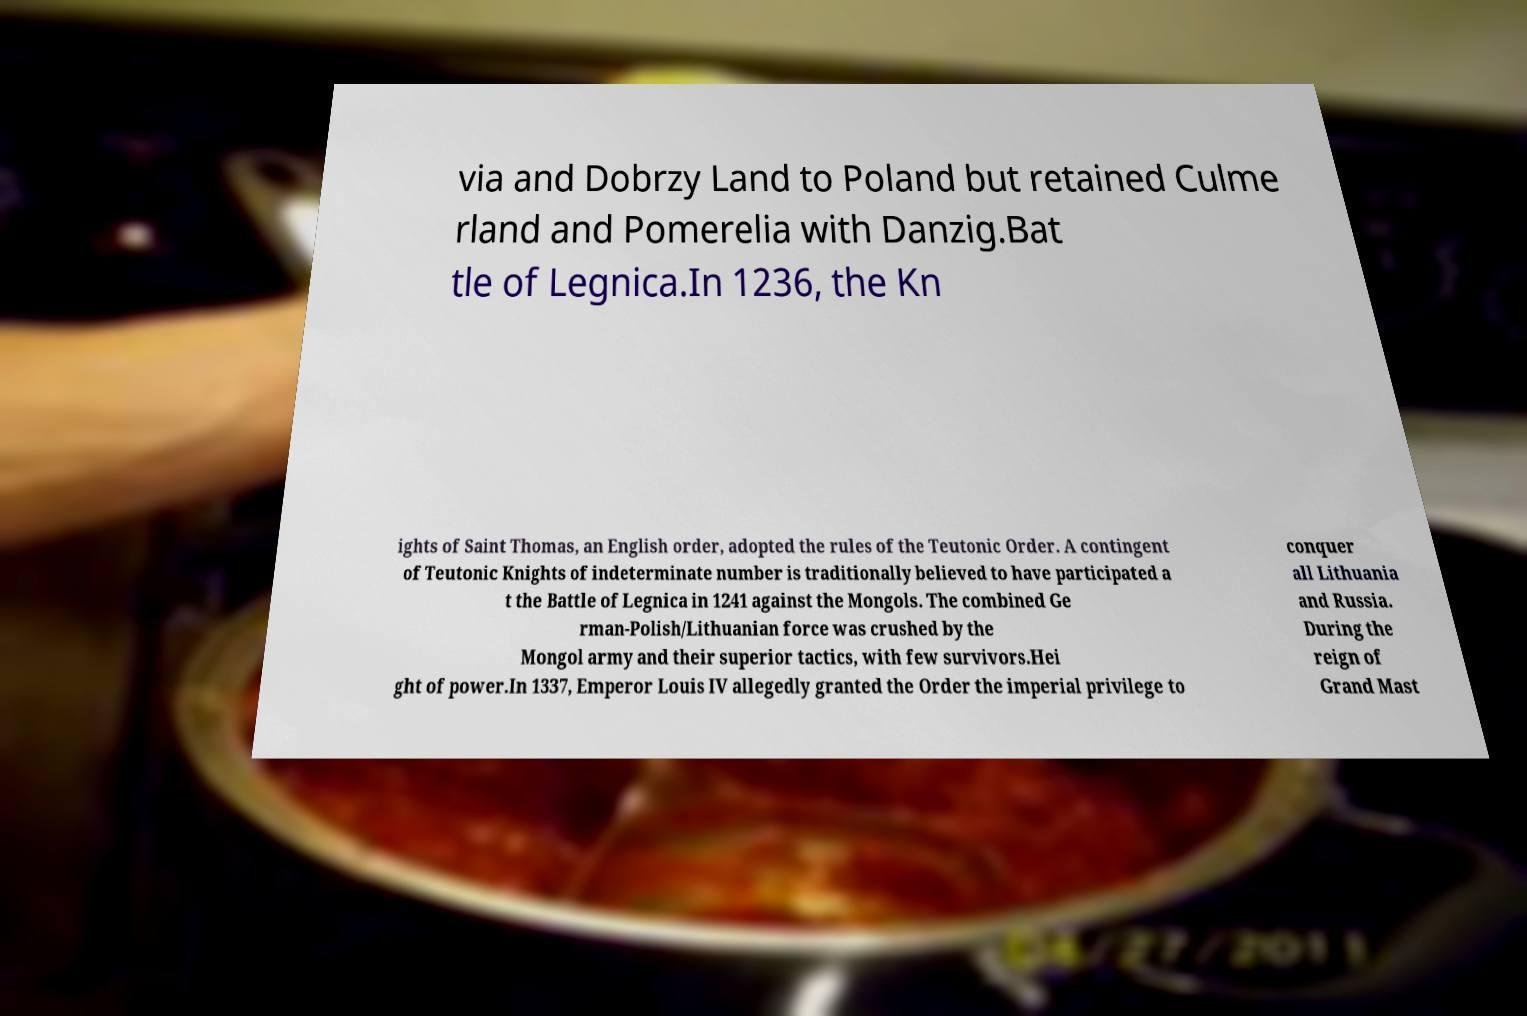I need the written content from this picture converted into text. Can you do that? via and Dobrzy Land to Poland but retained Culme rland and Pomerelia with Danzig.Bat tle of Legnica.In 1236, the Kn ights of Saint Thomas, an English order, adopted the rules of the Teutonic Order. A contingent of Teutonic Knights of indeterminate number is traditionally believed to have participated a t the Battle of Legnica in 1241 against the Mongols. The combined Ge rman-Polish/Lithuanian force was crushed by the Mongol army and their superior tactics, with few survivors.Hei ght of power.In 1337, Emperor Louis IV allegedly granted the Order the imperial privilege to conquer all Lithuania and Russia. During the reign of Grand Mast 